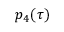<formula> <loc_0><loc_0><loc_500><loc_500>p _ { 4 } ( \tau )</formula> 